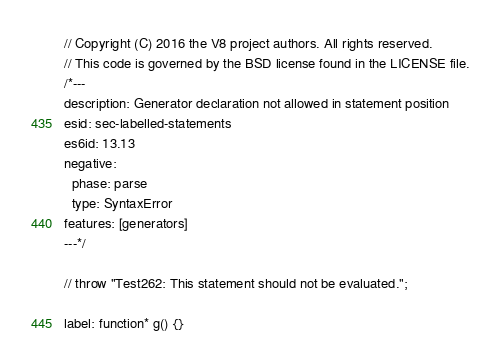Convert code to text. <code><loc_0><loc_0><loc_500><loc_500><_JavaScript_>// Copyright (C) 2016 the V8 project authors. All rights reserved.
// This code is governed by the BSD license found in the LICENSE file.
/*---
description: Generator declaration not allowed in statement position
esid: sec-labelled-statements
es6id: 13.13
negative:
  phase: parse
  type: SyntaxError
features: [generators]
---*/

// throw "Test262: This statement should not be evaluated.";

label: function* g() {}
</code> 